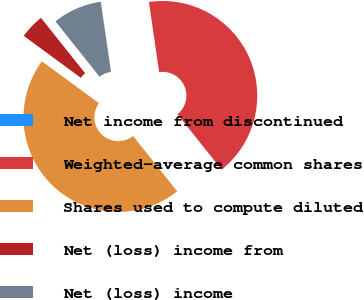Convert chart. <chart><loc_0><loc_0><loc_500><loc_500><pie_chart><fcel>Net income from discontinued<fcel>Weighted-average common shares<fcel>Shares used to compute diluted<fcel>Net (loss) income from<fcel>Net (loss) income<nl><fcel>0.0%<fcel>41.59%<fcel>45.8%<fcel>4.2%<fcel>8.41%<nl></chart> 